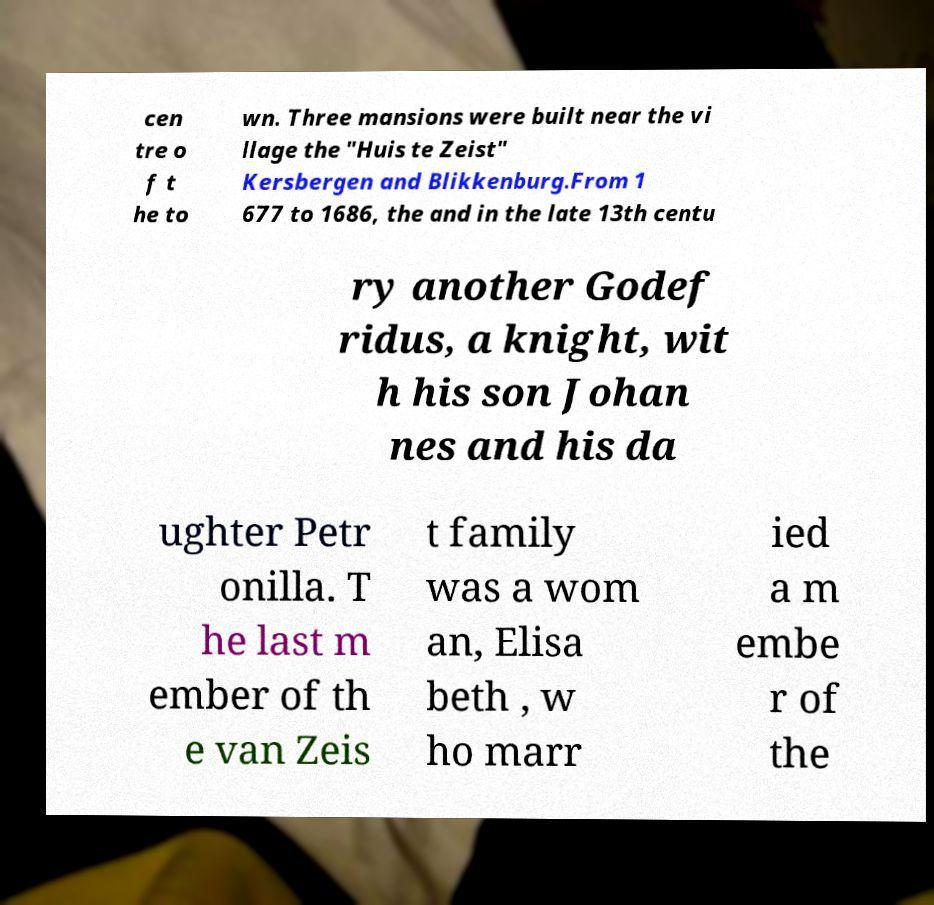Can you read and provide the text displayed in the image?This photo seems to have some interesting text. Can you extract and type it out for me? cen tre o f t he to wn. Three mansions were built near the vi llage the "Huis te Zeist" Kersbergen and Blikkenburg.From 1 677 to 1686, the and in the late 13th centu ry another Godef ridus, a knight, wit h his son Johan nes and his da ughter Petr onilla. T he last m ember of th e van Zeis t family was a wom an, Elisa beth , w ho marr ied a m embe r of the 